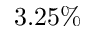<formula> <loc_0><loc_0><loc_500><loc_500>3 . 2 5 \%</formula> 